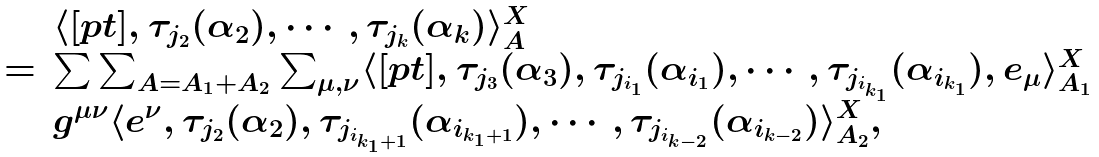Convert formula to latex. <formula><loc_0><loc_0><loc_500><loc_500>\begin{array} { l l } & \langle [ p t ] , \tau _ { j _ { 2 } } ( \alpha _ { 2 } ) , \cdots , \tau _ { j _ { k } } ( \alpha _ { k } ) \rangle ^ { X } _ { A } \\ = & \sum \sum _ { A = A _ { 1 } + A _ { 2 } } \sum _ { \mu , \nu } \langle [ p t ] , \tau _ { j _ { 3 } } ( \alpha _ { 3 } ) , \tau _ { j _ { i _ { 1 } } } ( \alpha _ { i _ { 1 } } ) , \cdots , \tau _ { j _ { i _ { k _ { 1 } } } } ( \alpha _ { i _ { k _ { 1 } } } ) , e _ { \mu } \rangle ^ { X } _ { A _ { 1 } } \\ & g ^ { \mu \nu } \langle e ^ { \nu } , \tau _ { j _ { 2 } } ( \alpha _ { 2 } ) , \tau _ { j _ { i _ { k _ { 1 } + 1 } } } ( \alpha _ { i _ { k _ { 1 } + 1 } } ) , \cdots , \tau _ { j _ { i _ { k - 2 } } } ( \alpha _ { i _ { k - 2 } } ) \rangle ^ { X } _ { A _ { 2 } } , \end{array}</formula> 